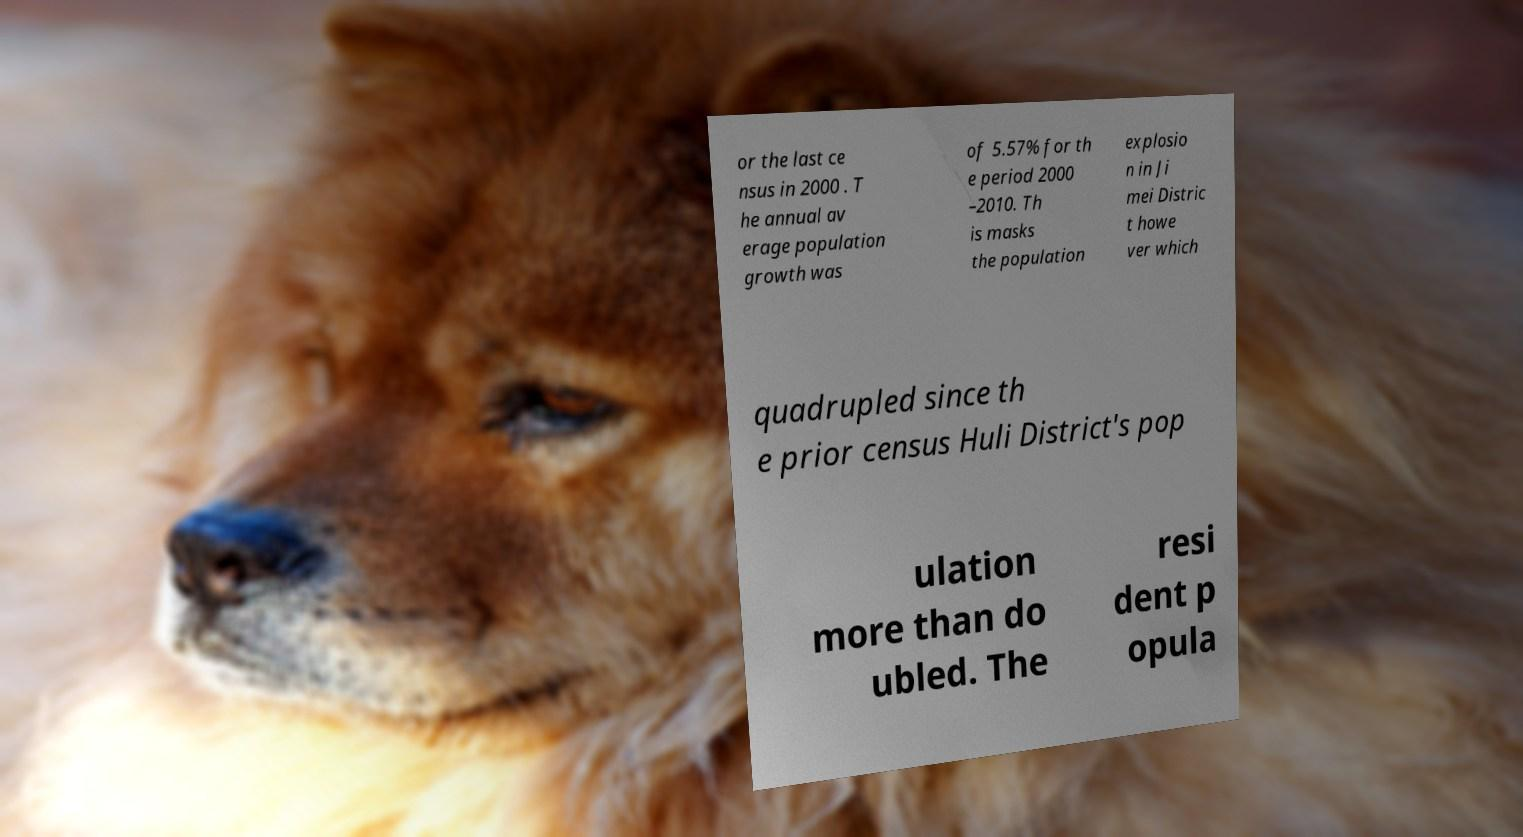Please identify and transcribe the text found in this image. or the last ce nsus in 2000 . T he annual av erage population growth was of 5.57% for th e period 2000 –2010. Th is masks the population explosio n in Ji mei Distric t howe ver which quadrupled since th e prior census Huli District's pop ulation more than do ubled. The resi dent p opula 